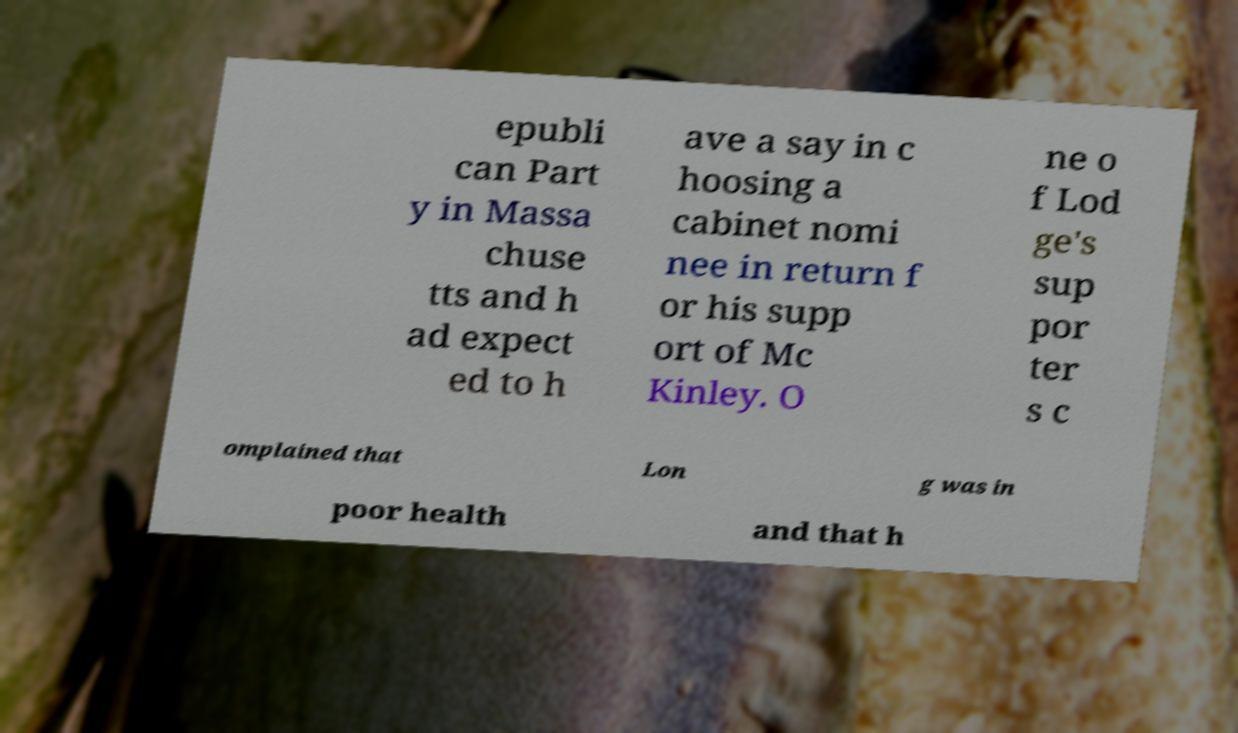Could you assist in decoding the text presented in this image and type it out clearly? epubli can Part y in Massa chuse tts and h ad expect ed to h ave a say in c hoosing a cabinet nomi nee in return f or his supp ort of Mc Kinley. O ne o f Lod ge's sup por ter s c omplained that Lon g was in poor health and that h 